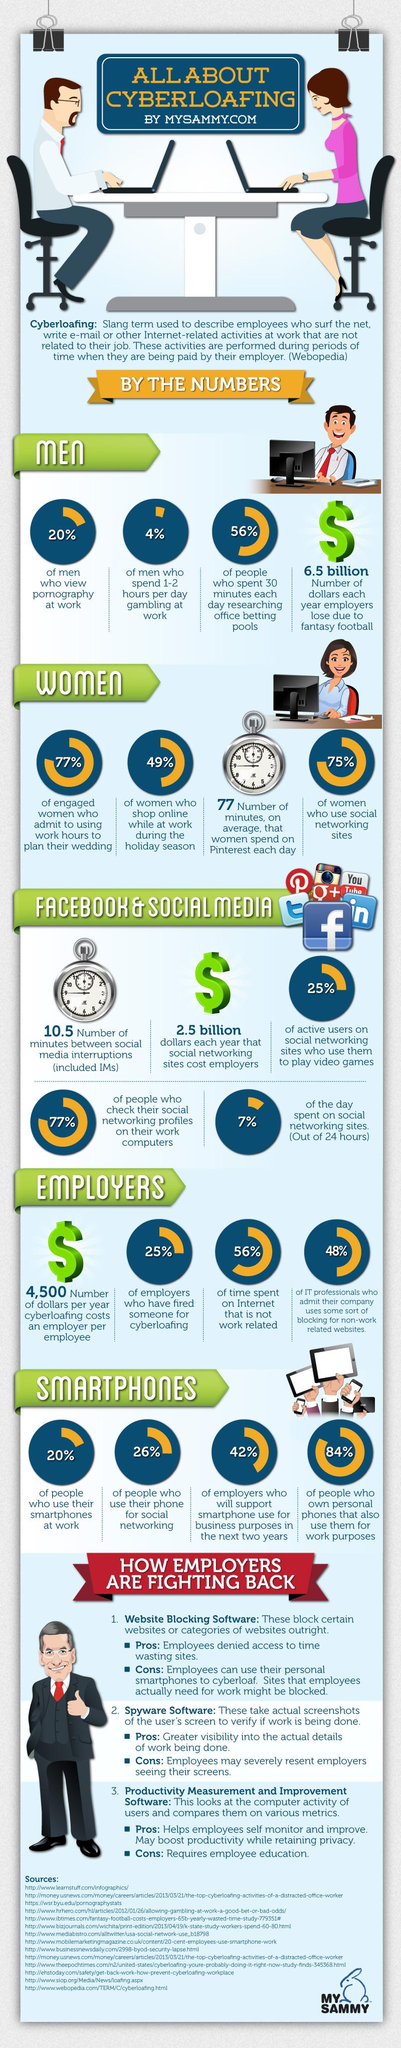Specify some key components in this picture. According to a recent survey, during the holiday season, 49% of women shop online while at work. According to a recent survey, a staggering 80% of people do not use smartphones at work. According to a survey, 25% of employers have fired an employee for cyberloafing, which is defined as unauthorized use of work equipment or resources for personal purposes during working hours. According to a recent survey, 26% of people use smartphones for social networking. A study reveals that 20% of men view pornography at work. 